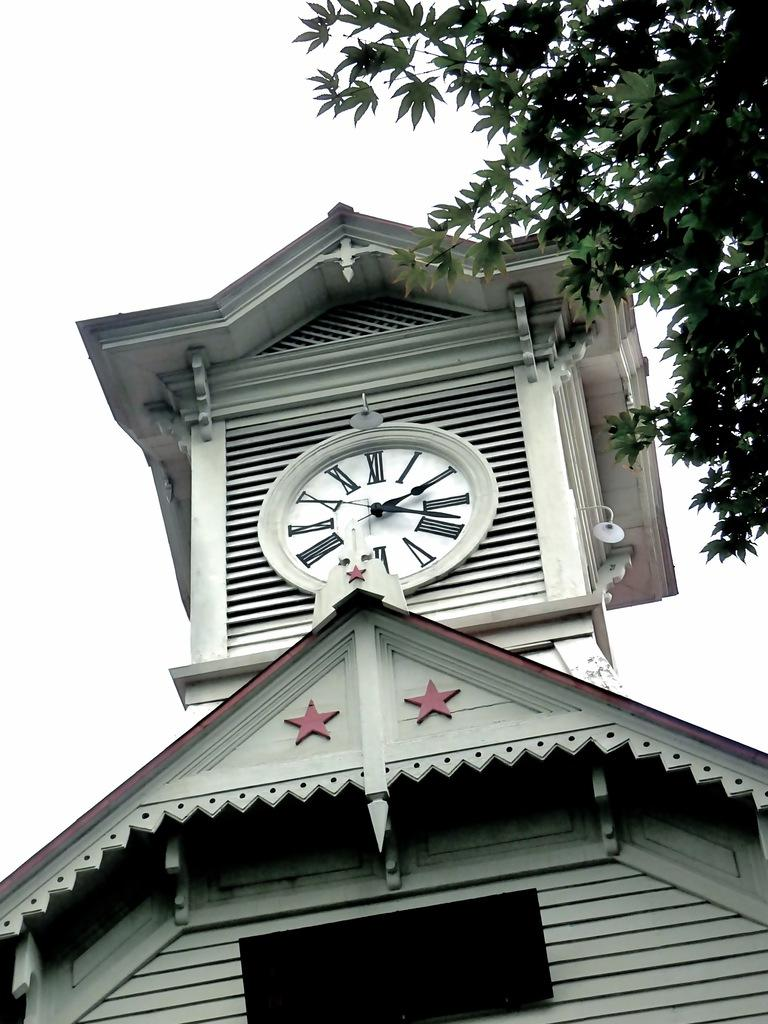<image>
Create a compact narrative representing the image presented. a clock tower with roman numerals like XII sits atop a wooden house 